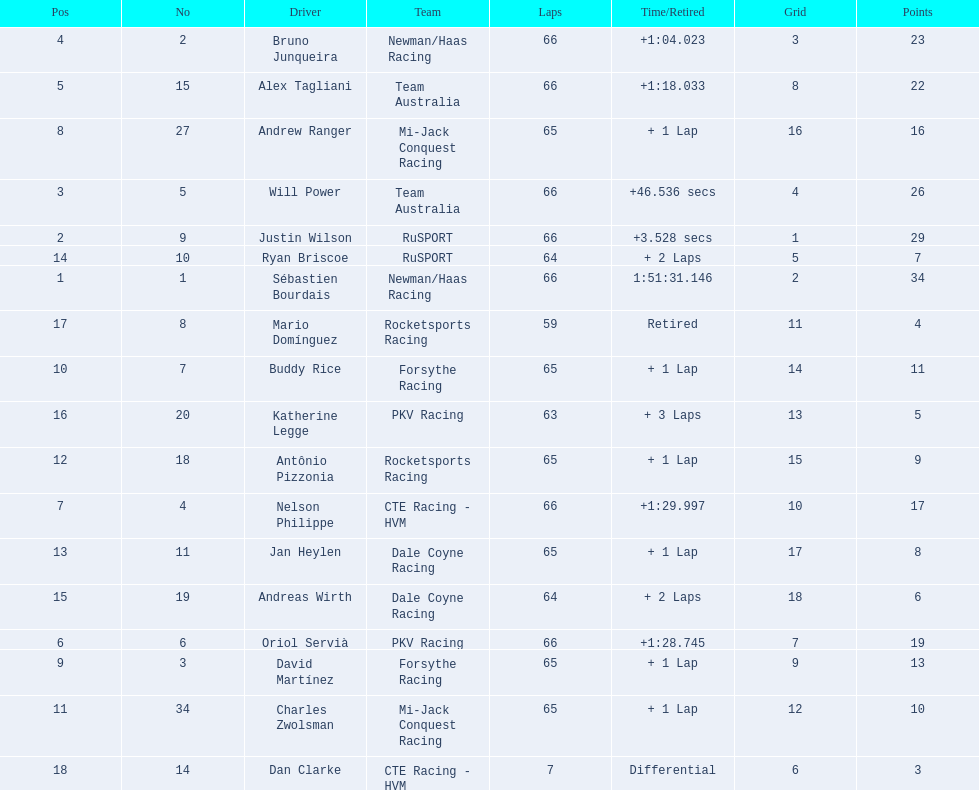Who are the drivers? Sébastien Bourdais, Justin Wilson, Will Power, Bruno Junqueira, Alex Tagliani, Oriol Servià, Nelson Philippe, Andrew Ranger, David Martínez, Buddy Rice, Charles Zwolsman, Antônio Pizzonia, Jan Heylen, Ryan Briscoe, Andreas Wirth, Katherine Legge, Mario Domínguez, Dan Clarke. What are their numbers? 1, 9, 5, 2, 15, 6, 4, 27, 3, 7, 34, 18, 11, 10, 19, 20, 8, 14. What are their positions? 1, 2, 3, 4, 5, 6, 7, 8, 9, 10, 11, 12, 13, 14, 15, 16, 17, 18. Which driver has the same number and position? Sébastien Bourdais. Which drivers scored at least 10 points? Sébastien Bourdais, Justin Wilson, Will Power, Bruno Junqueira, Alex Tagliani, Oriol Servià, Nelson Philippe, Andrew Ranger, David Martínez, Buddy Rice, Charles Zwolsman. Of those drivers, which ones scored at least 20 points? Sébastien Bourdais, Justin Wilson, Will Power, Bruno Junqueira, Alex Tagliani. Of those 5, which driver scored the most points? Sébastien Bourdais. 